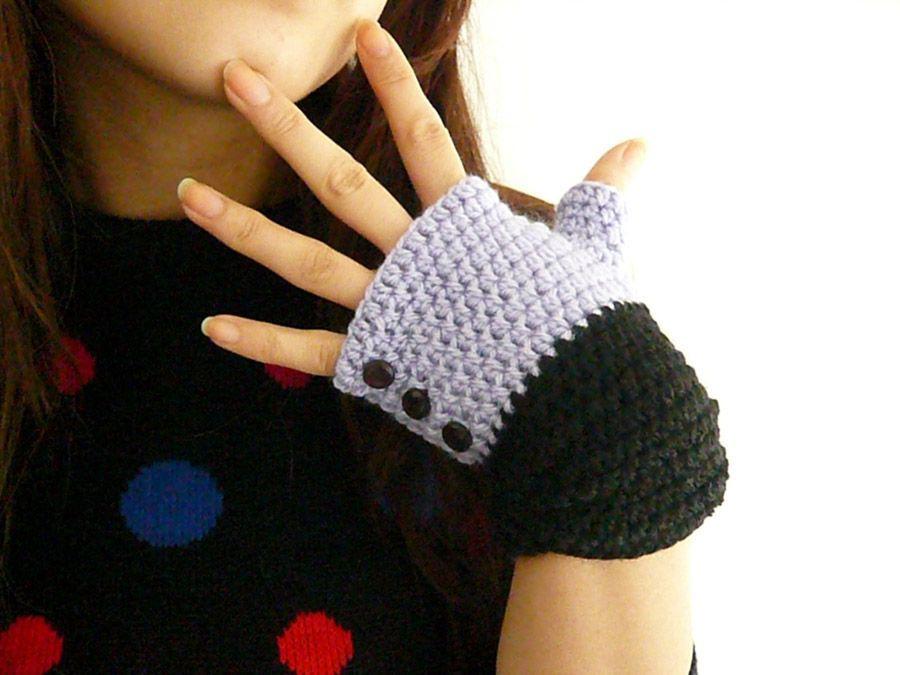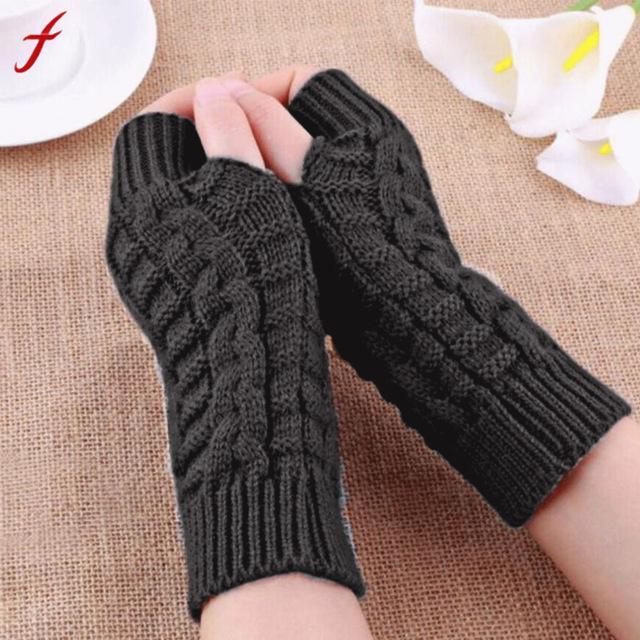The first image is the image on the left, the second image is the image on the right. Assess this claim about the two images: "The left and right image contains the same number of sets of fingerless mittens.". Correct or not? Answer yes or no. No. The first image is the image on the left, the second image is the image on the right. Considering the images on both sides, is "One image shows half mittens that leave all fingers exposed and are made of one color of yarn, and the other image contains a half mitten with at least one button." valid? Answer yes or no. Yes. 